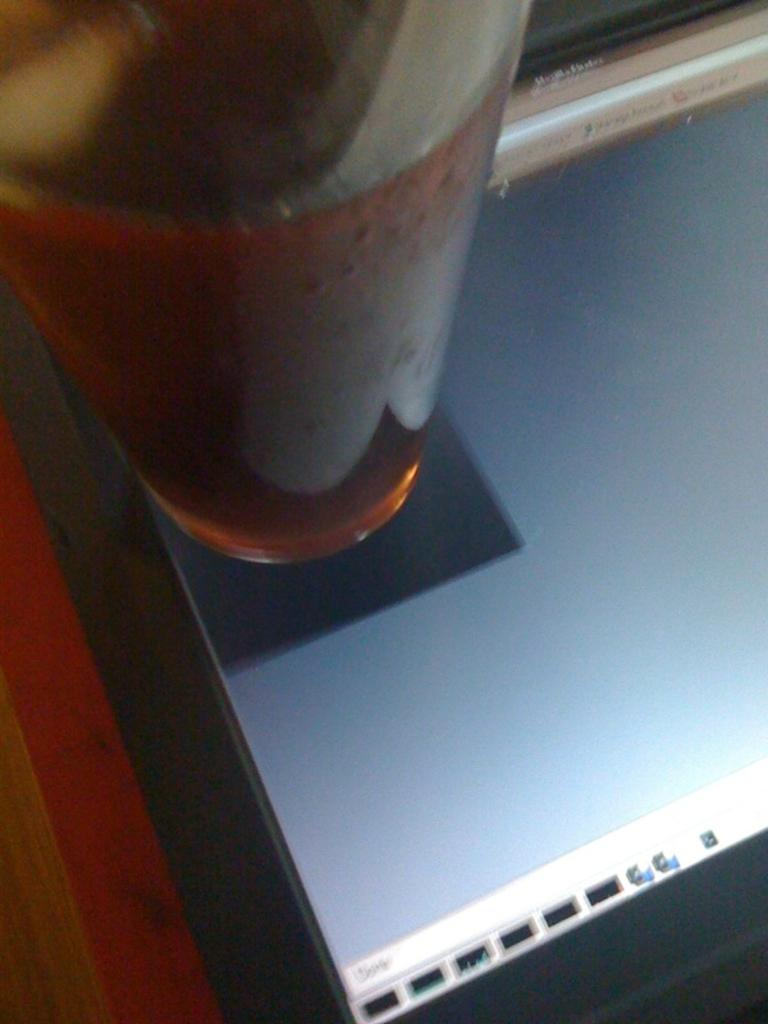What object can be seen in the image that is typically used for drinking? There is a glass in the image that is typically used for drinking. What electronic device is visible in the image? The laptop screen is visible in the image. How many flies can be seen on the laptop screen in the image? There are no flies visible on the laptop screen in the image. What type of card is present in the image? There is no card present in the image. 